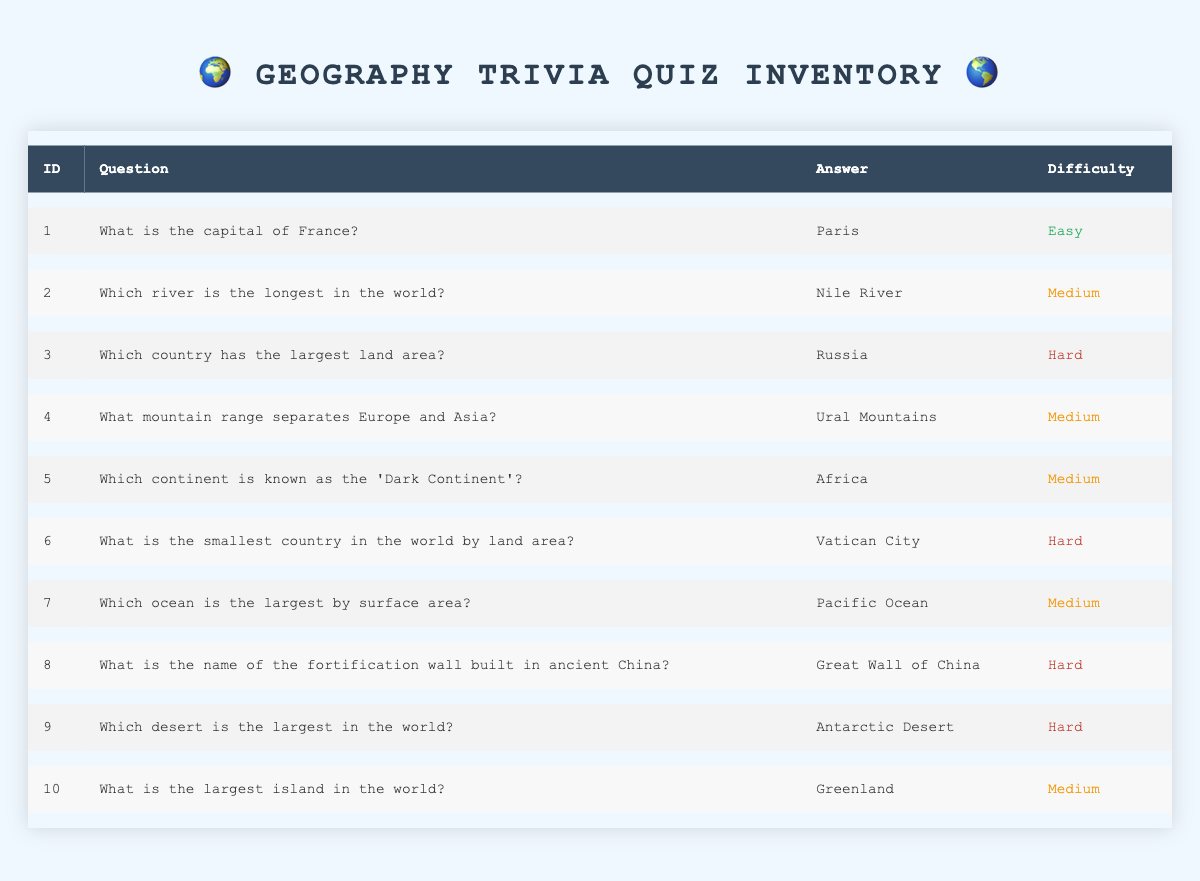What is the capital of France? The question directly asks for a specific value in the table. By referring to the first row, we see that the capital of France is listed as Paris.
Answer: Paris Which country has the largest land area? According to the table, the country with the largest land area is specified in the third row. It lists Russia as the answer.
Answer: Russia How many questions are categorized as 'Medium' difficulty? To find this, we need to count the rows where the difficulty is marked as 'Medium.' There are a total of 4 questions (IDs 2, 4, 5, 7, and 10) that meet this criterion.
Answer: 5 Is the Nile River the answer to the question about the longest river in the world? The table indicates that the Nile River is indeed the answer to that specific question found in the second row, making the statement true.
Answer: Yes Which question has the smallest country as the answer? The sixth row of the table addresses this question, stating that the answer is Vatican City, which is recognized as the smallest country by land area.
Answer: What is the smallest country in the world by land area? Which questions are categorized as 'Hard' difficulty? To answer this question, we identify the rows whose difficulty is labeled 'Hard.' Those rows (IDs 3, 6, 8, and 9) indicate the questions, which are: "Which country has the largest land area?", "What is the smallest country in the world by land area?", "What is the name of the fortification wall built in ancient China?", and "Which desert is the largest in the world?"
Answer: Which country has the largest land area?, What is the smallest country in the world by land area?, What is the name of the fortification wall built in ancient China?, Which desert is the largest in the world? What is the average difficulty level across all questions? The difficulty levels can be considered as numerical values (Easy = 1, Medium = 2, Hard = 3). There are 1 Easy, 5 Mediums, and 4 Hards, which compute as follows: (1*1 + 5*2 + 4*3) / 10 = 2.
Answer: 2 What is the relationship between the largest island and the Pacific Ocean in this trivia? In the table, we note that the largest island (Greenland) is mentioned in the tenth row, and the largest ocean (Pacific Ocean) is referenced in the seventh row. They are separate entities. There is no direct relationship between them in the context of the table.
Answer: No direct relationship How many questions reference a continent in their answers? By examining the table, we identify the questions for which a continent name is given in the answer. There are two such questions related to Africa (question 5). Therefore, there is a total of 1 continent mentioned across the documented answers.
Answer: 1 